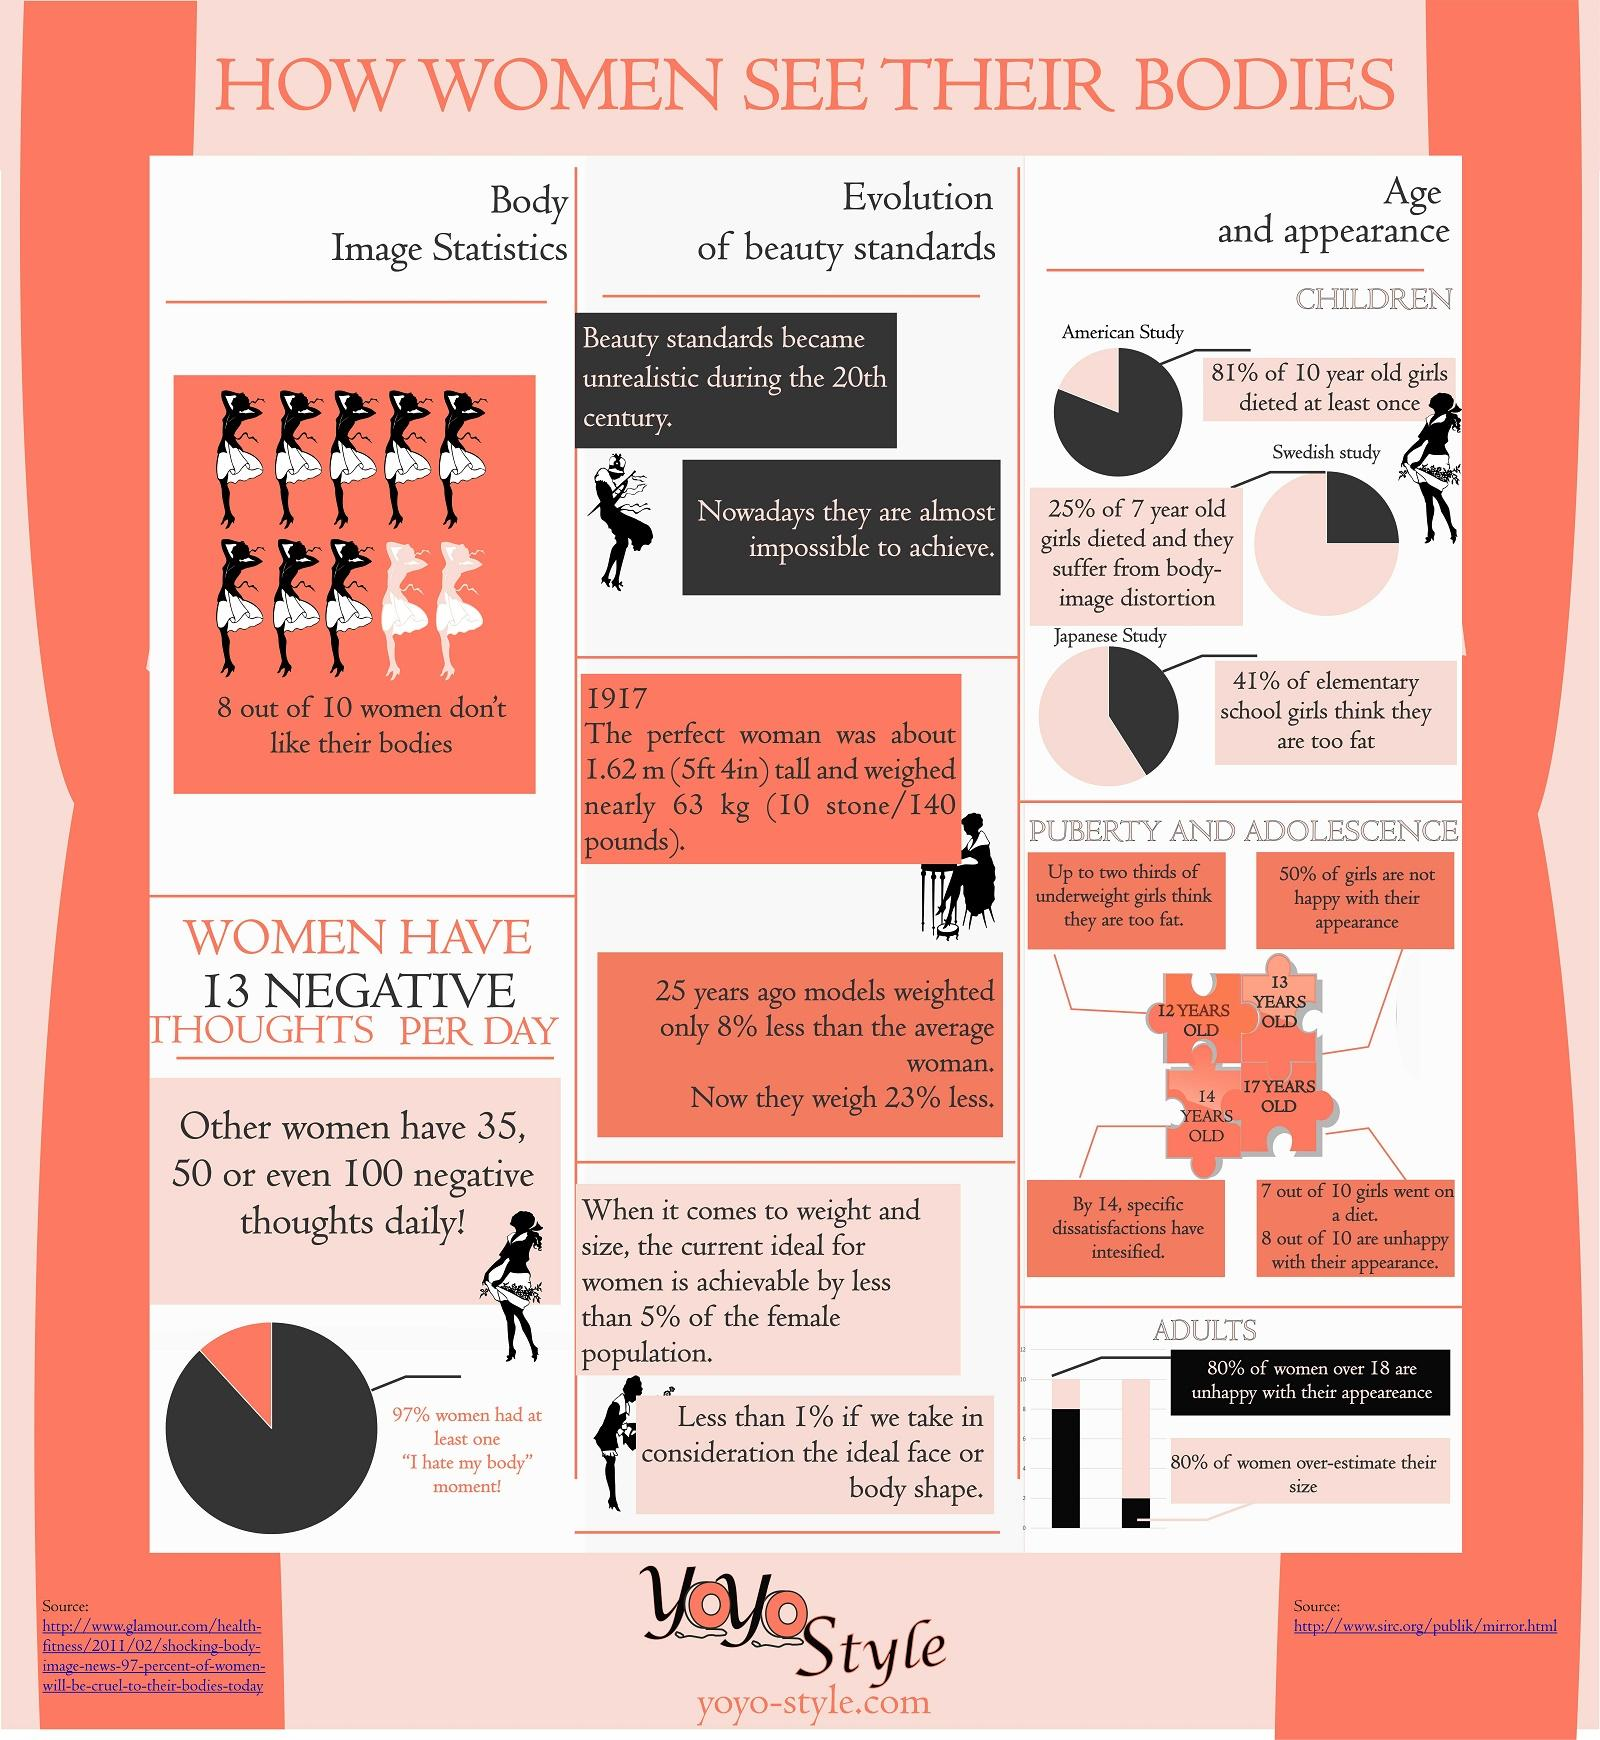Point out several critical features in this image. According to the data, Sweden had the highest percentage of non-dieting girls in the age group of seven, with 75% of girls falling into this category. According to a survey of 12-year-olds, 66.67% of them believe they are too fat. A recent Japanese study found that 59% of the female participants did not feel they were too fat. According to research, 13-year-old girls are generally satisfied with their physical appearance. 